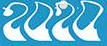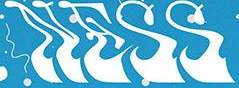What words can you see in these images in sequence, separated by a semicolon? 2020; NESS 